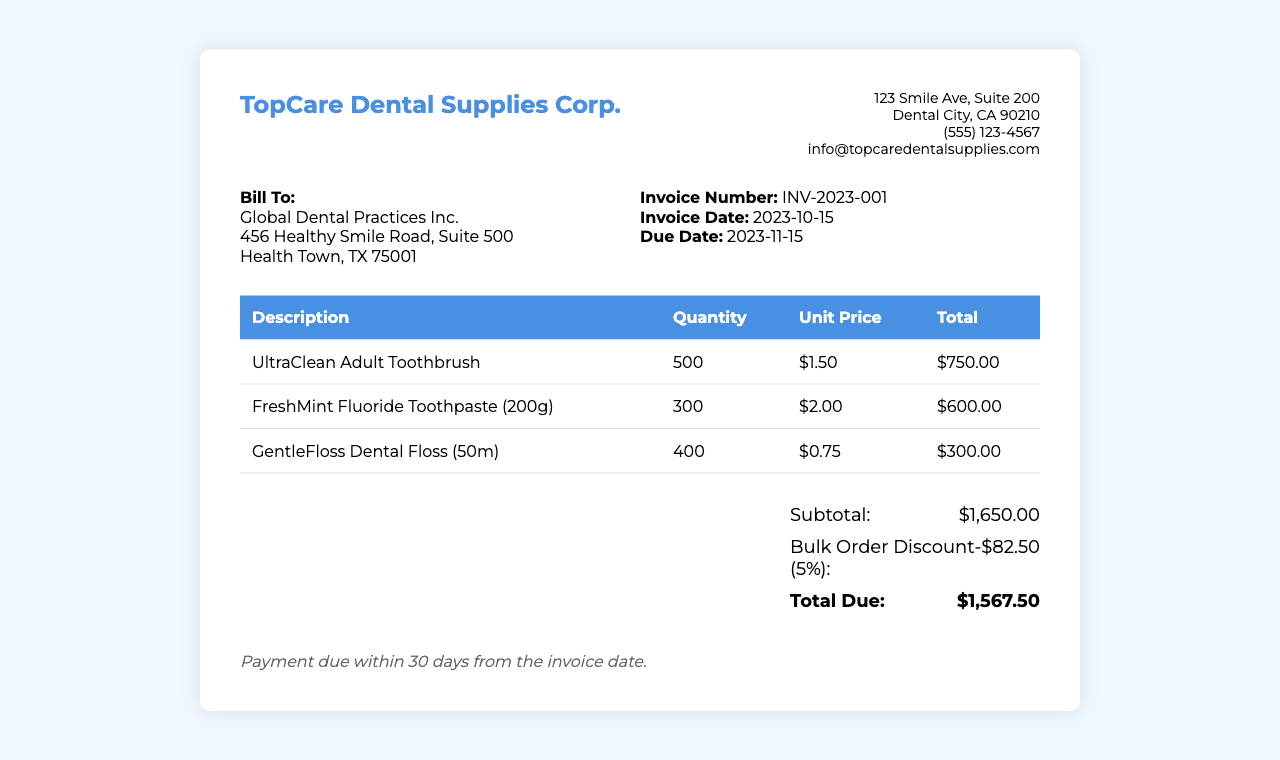What is the invoice number? The invoice number is specifically mentioned in the document under the invoice info section.
Answer: INV-2023-001 Who is billed for this invoice? The billing information is listed in the client info section of the document.
Answer: Global Dental Practices Inc What is the total due amount? The total due amount is clearly stated in the total section of the document.
Answer: $1,567.50 What is the subtotal before the discount? The subtotal amount is shown in the total section before the discount is applied.
Answer: $1,650.00 What percentage is the bulk order discount? The discount percentage is indicated next to the discount amount in the total section.
Answer: 5% What date is the invoice due? The due date is mentioned in the invoice info section of the document.
Answer: 2023-11-15 How many units of GentleFloss Dental Floss were ordered? The quantity ordered for GentleFloss is found in the items section of the invoice.
Answer: 400 What is the unit price of the UltraClean Adult Toothbrush? The unit price for the toothbrush is listed in the items section of the invoice.
Answer: $1.50 What is the payment term for the invoice? The payment terms are stated at the bottom of the invoice in italicized text.
Answer: Payment due within 30 days from the invoice date 